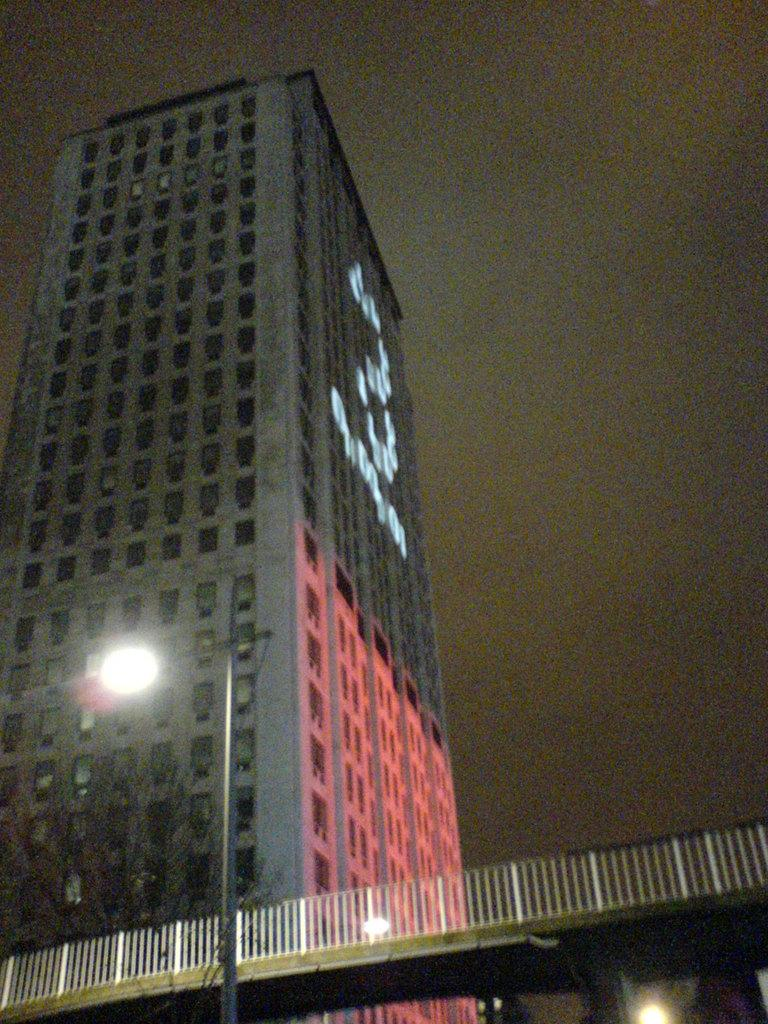What type of structure is visible in the image? There is there a building in the image? What can be seen in front of the building? There are trees, a bridge, and a street light pole in front of the building. What is visible behind the building? The sky is visible behind the building. What type of string is being used to control the building in the image? There is no string or control mechanism present in the image; the building is a stationary structure. 